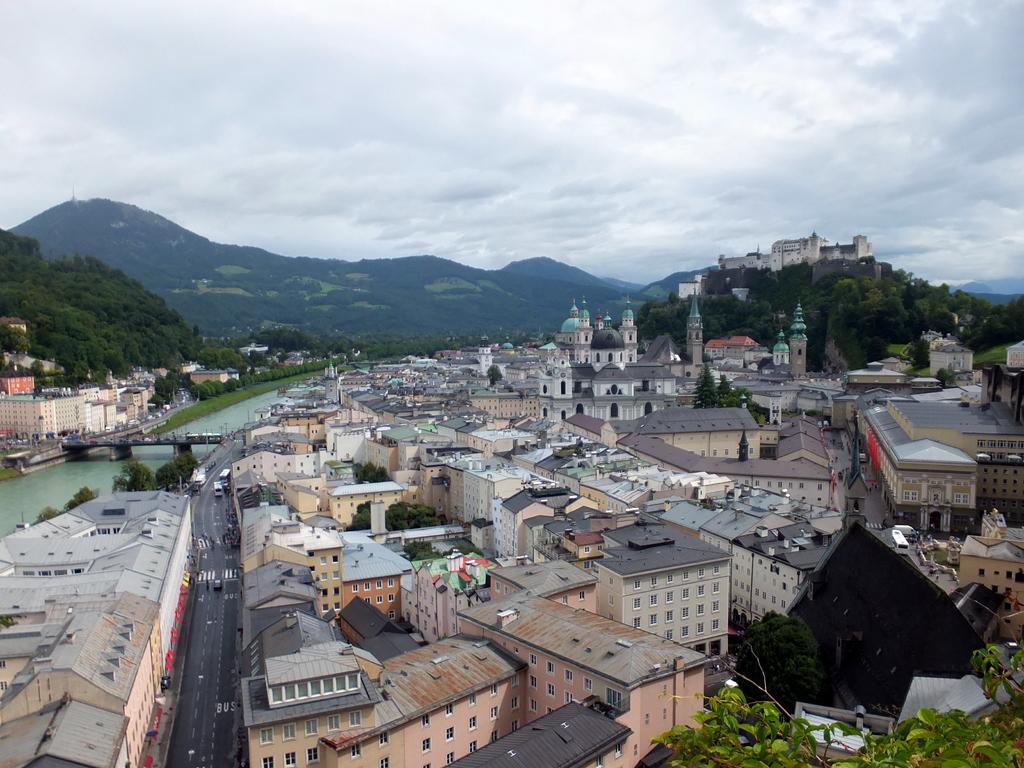How would you summarize this image in a sentence or two? In this image, we can see so many houses, buildings, trees, water, bridge, roads and vehicles. Background we can see hills, trees and cloudy sky. 